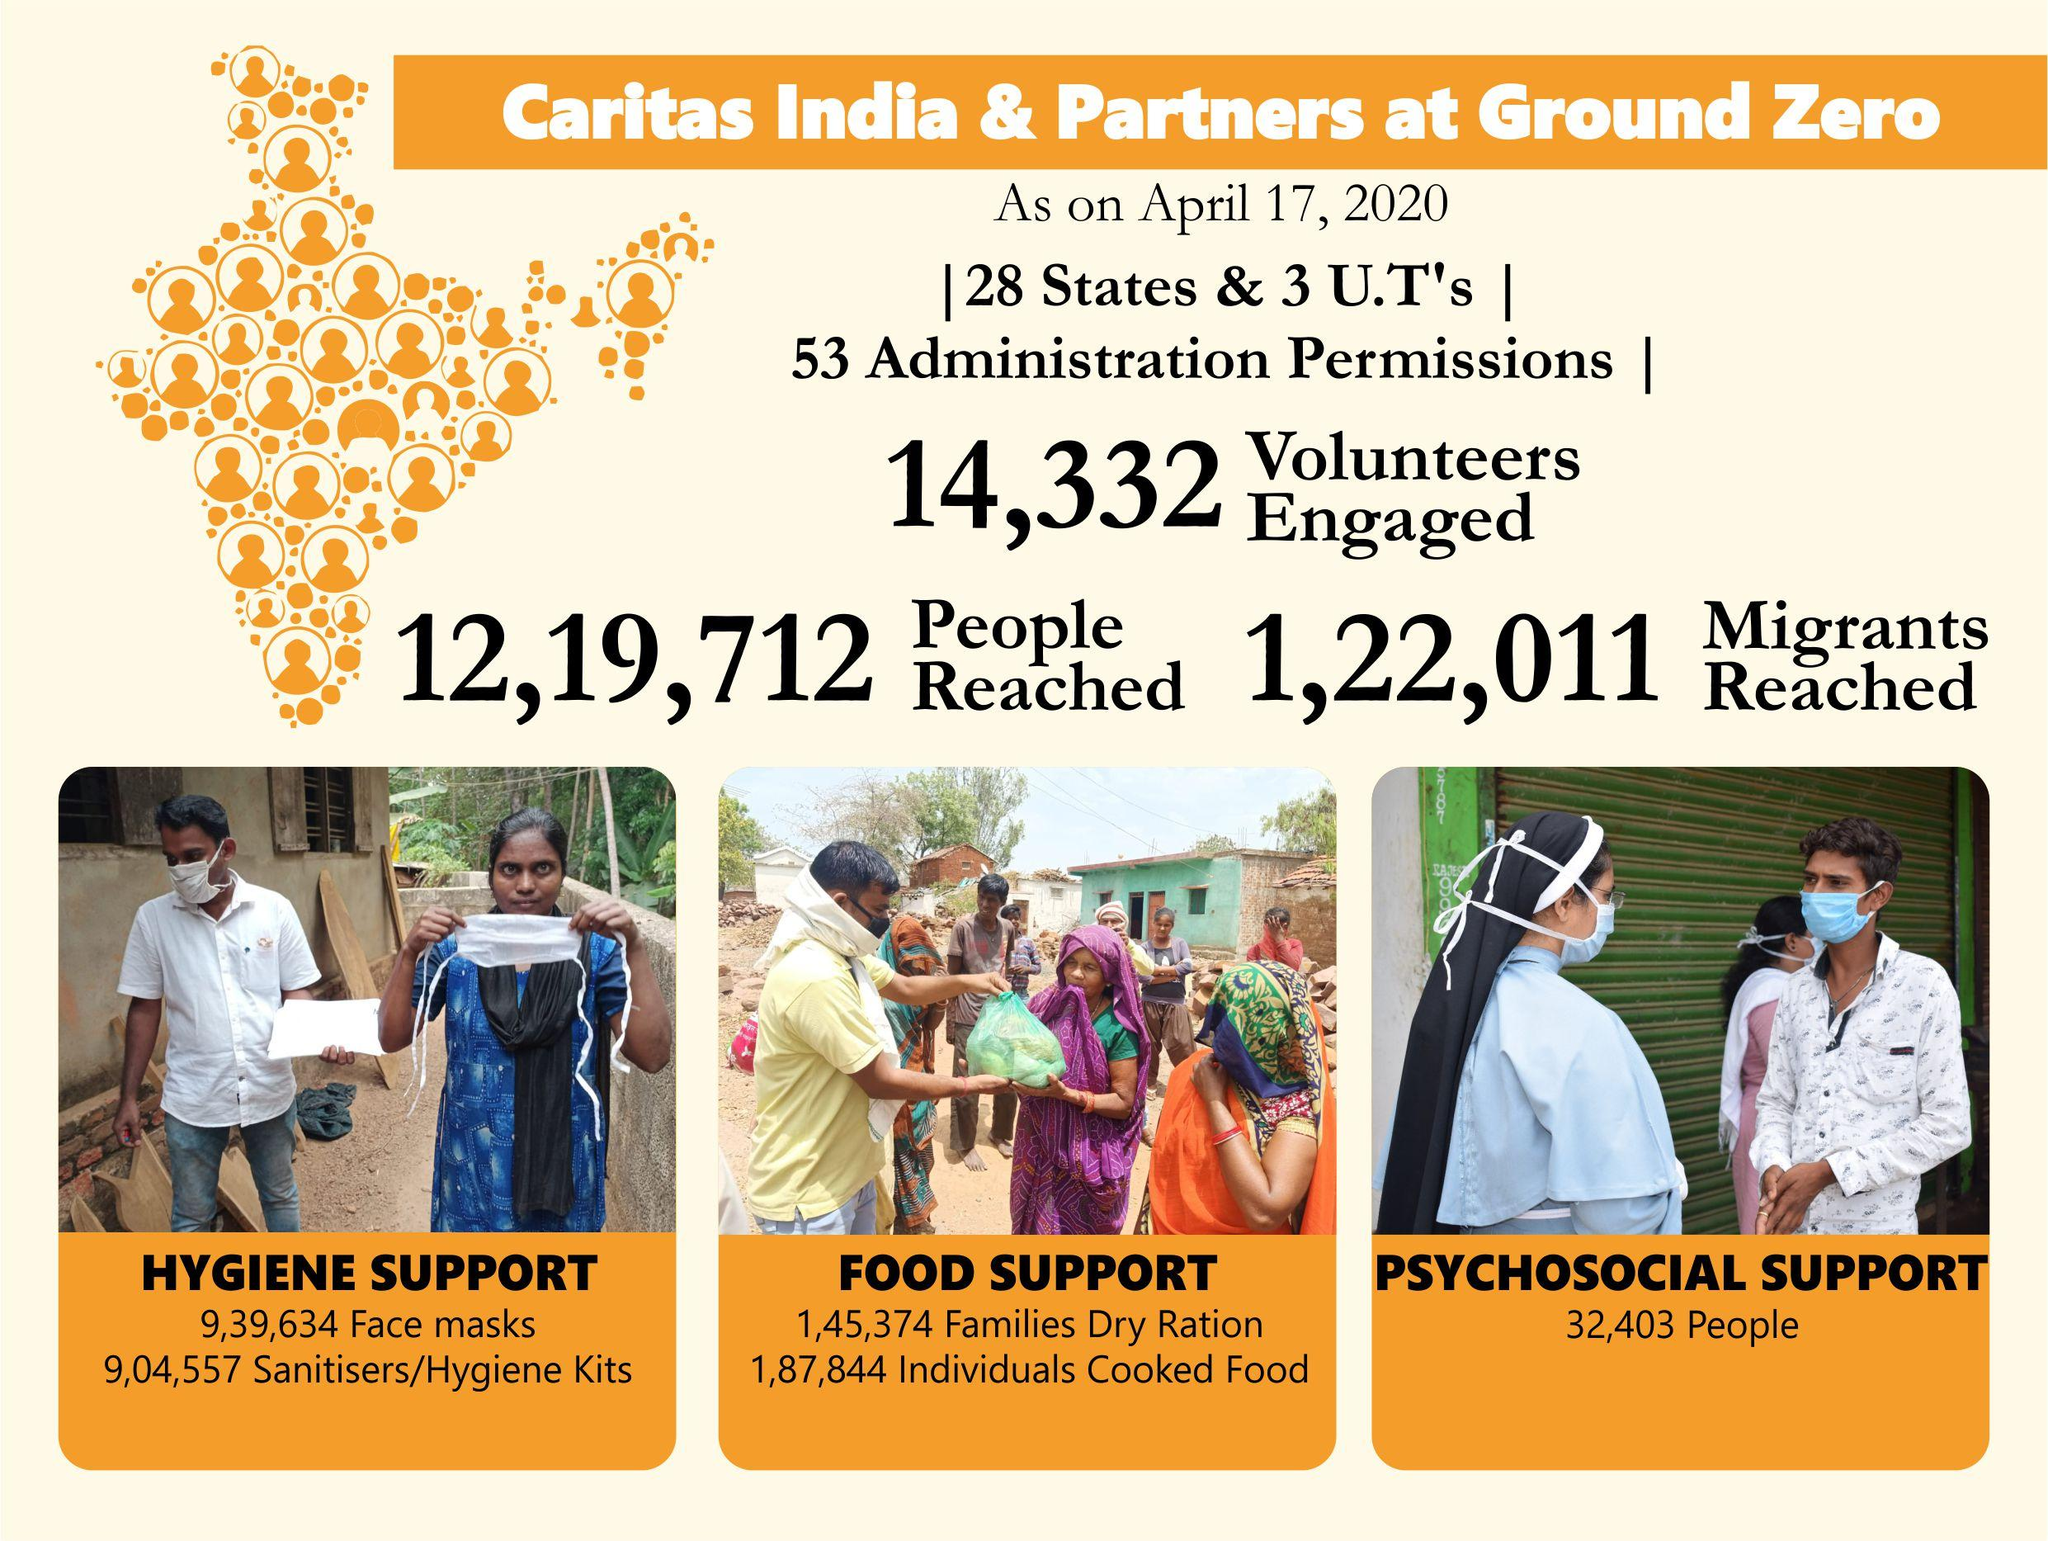Give some essential details in this illustration. As of April 17, 2020, a total of 32,403 individuals had received psychosocial support from Caritas India & Partners. 